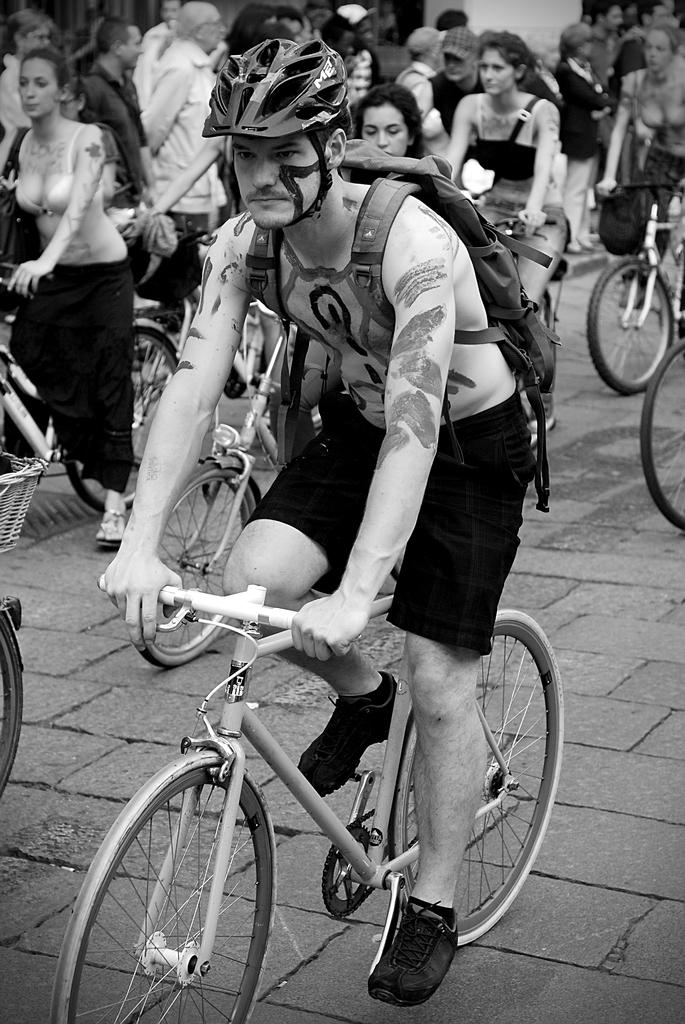What is the color scheme of the image? The image is black and white. What are the persons in the image doing? The persons in the image are riding bicycles. Are there any other people visible in the image? Yes, there are persons standing in the background of the image. How many eggs are visible in the image? There are no eggs present in the image. Can you tell me the credit score of the person riding the bicycle? There is no information about credit scores in the image. 